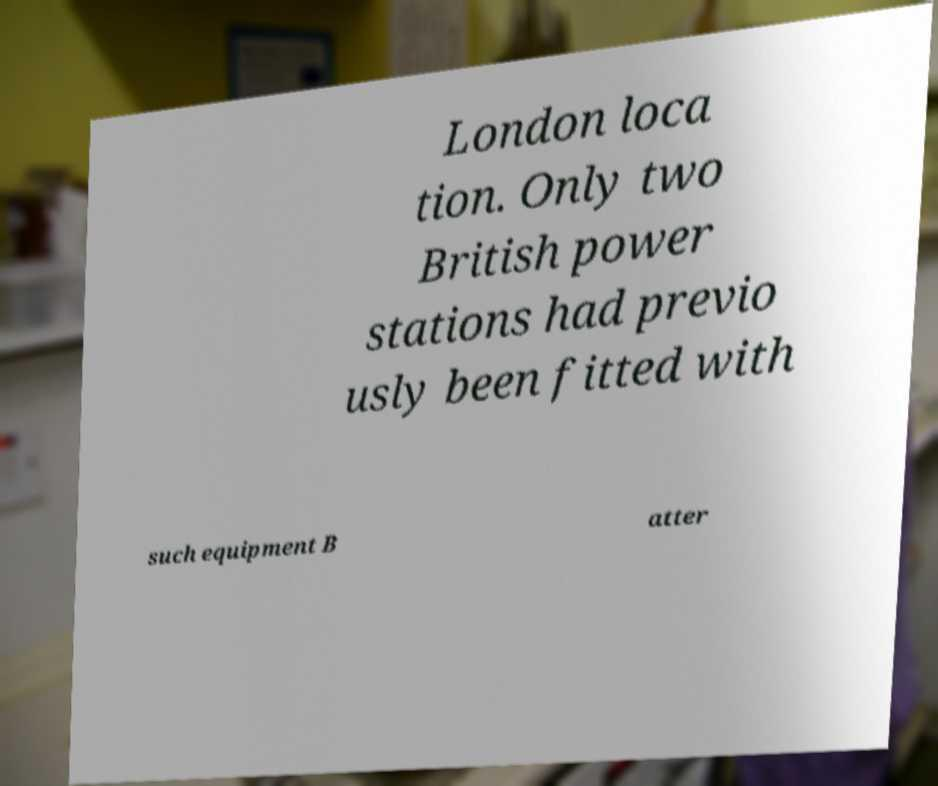For documentation purposes, I need the text within this image transcribed. Could you provide that? London loca tion. Only two British power stations had previo usly been fitted with such equipment B atter 